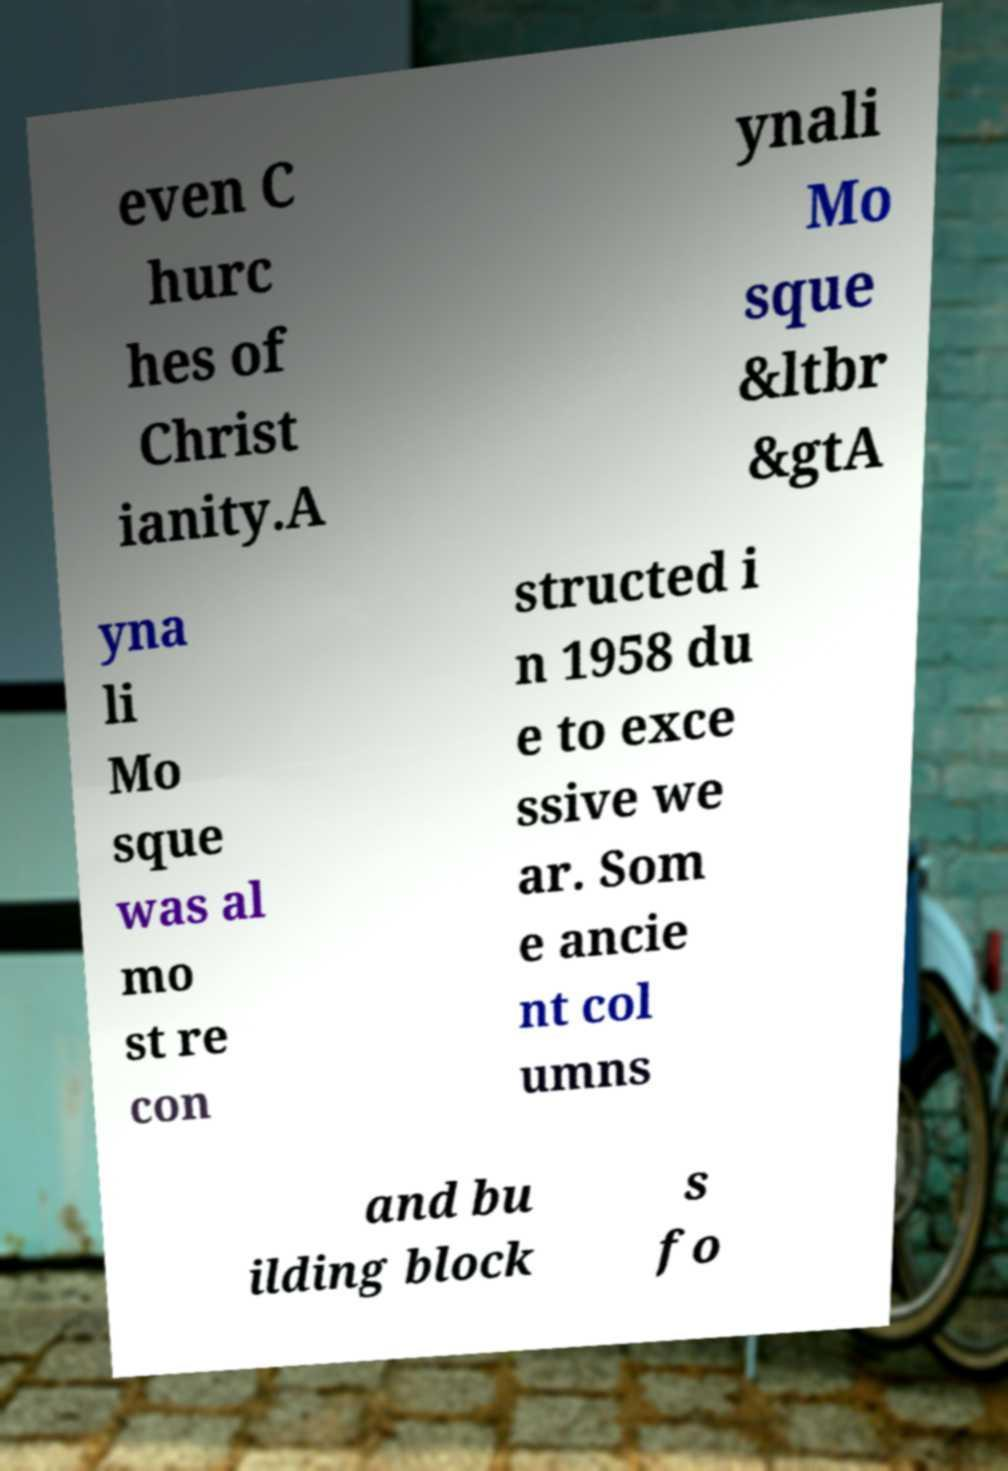For documentation purposes, I need the text within this image transcribed. Could you provide that? even C hurc hes of Christ ianity.A ynali Mo sque &ltbr &gtA yna li Mo sque was al mo st re con structed i n 1958 du e to exce ssive we ar. Som e ancie nt col umns and bu ilding block s fo 